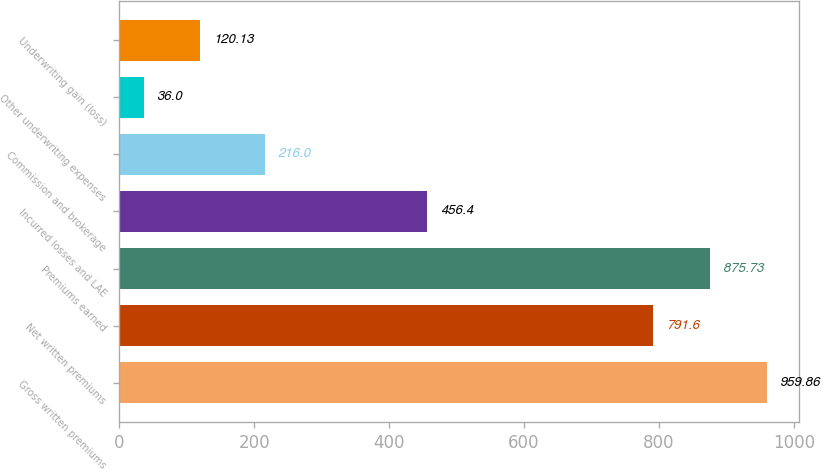Convert chart to OTSL. <chart><loc_0><loc_0><loc_500><loc_500><bar_chart><fcel>Gross written premiums<fcel>Net written premiums<fcel>Premiums earned<fcel>Incurred losses and LAE<fcel>Commission and brokerage<fcel>Other underwriting expenses<fcel>Underwriting gain (loss)<nl><fcel>959.86<fcel>791.6<fcel>875.73<fcel>456.4<fcel>216<fcel>36<fcel>120.13<nl></chart> 